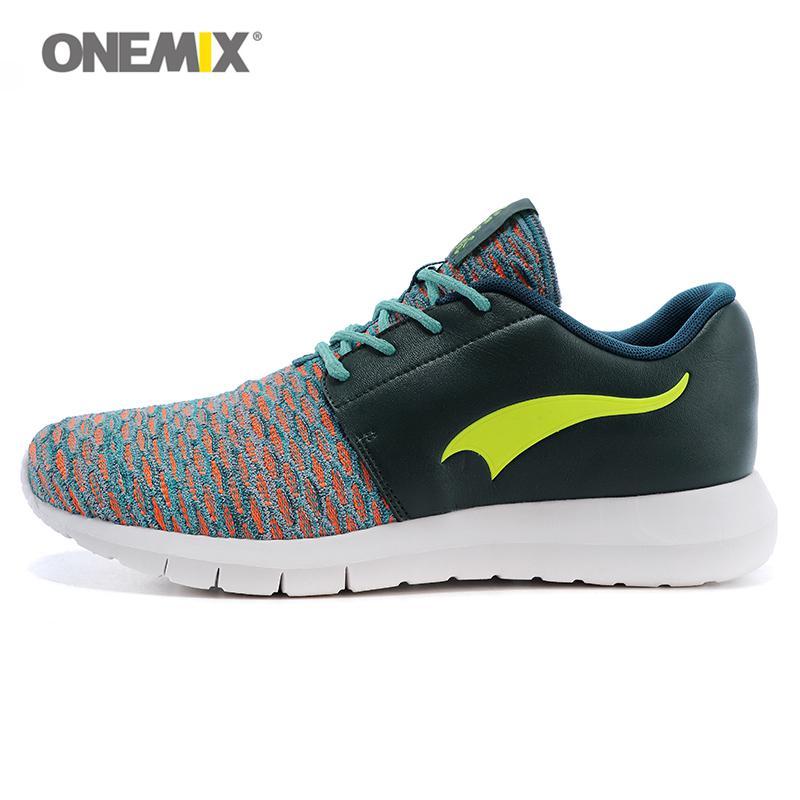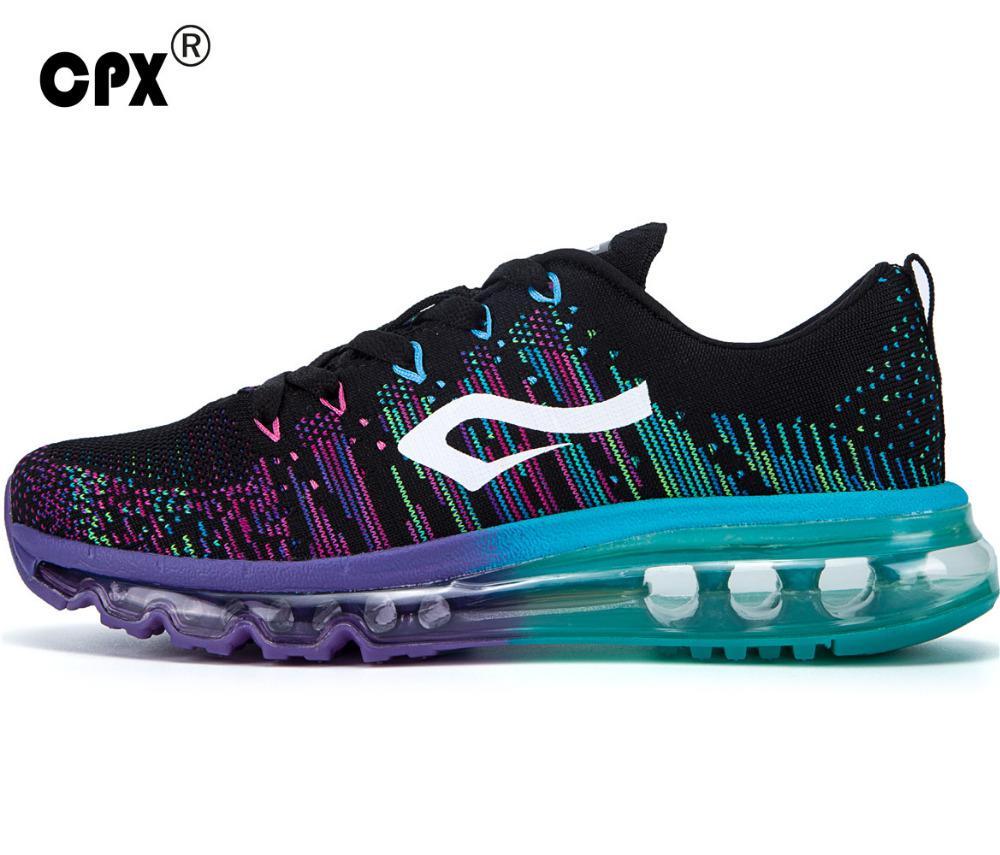The first image is the image on the left, the second image is the image on the right. Analyze the images presented: Is the assertion "All shoes are laced with black shoestrings." valid? Answer yes or no. No. The first image is the image on the left, the second image is the image on the right. Evaluate the accuracy of this statement regarding the images: "One shoe has a blue heel.". Is it true? Answer yes or no. Yes. 